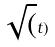Convert formula to latex. <formula><loc_0><loc_0><loc_500><loc_500>\sqrt { ( } t )</formula> 